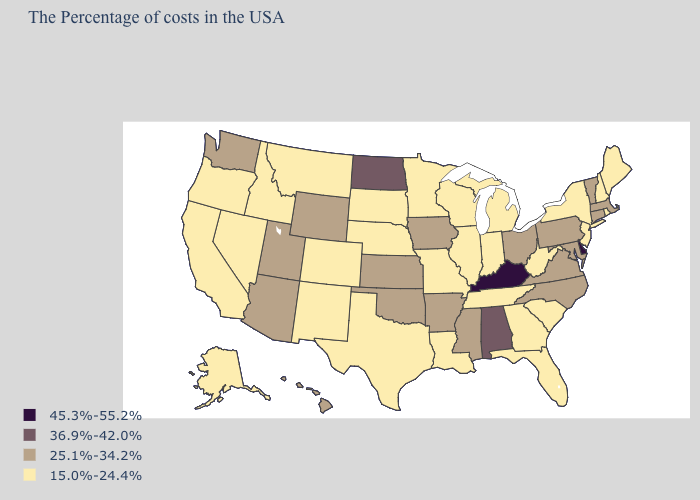Name the states that have a value in the range 45.3%-55.2%?
Be succinct. Delaware, Kentucky. What is the lowest value in the Northeast?
Write a very short answer. 15.0%-24.4%. Does Hawaii have a lower value than Kentucky?
Concise answer only. Yes. Name the states that have a value in the range 15.0%-24.4%?
Give a very brief answer. Maine, Rhode Island, New Hampshire, New York, New Jersey, South Carolina, West Virginia, Florida, Georgia, Michigan, Indiana, Tennessee, Wisconsin, Illinois, Louisiana, Missouri, Minnesota, Nebraska, Texas, South Dakota, Colorado, New Mexico, Montana, Idaho, Nevada, California, Oregon, Alaska. Does West Virginia have the lowest value in the USA?
Keep it brief. Yes. Does the first symbol in the legend represent the smallest category?
Quick response, please. No. Does New Jersey have the same value as Vermont?
Concise answer only. No. Name the states that have a value in the range 45.3%-55.2%?
Give a very brief answer. Delaware, Kentucky. Which states have the highest value in the USA?
Write a very short answer. Delaware, Kentucky. Does New Hampshire have the same value as Indiana?
Short answer required. Yes. What is the value of Indiana?
Short answer required. 15.0%-24.4%. Name the states that have a value in the range 25.1%-34.2%?
Quick response, please. Massachusetts, Vermont, Connecticut, Maryland, Pennsylvania, Virginia, North Carolina, Ohio, Mississippi, Arkansas, Iowa, Kansas, Oklahoma, Wyoming, Utah, Arizona, Washington, Hawaii. Does New Jersey have the lowest value in the USA?
Keep it brief. Yes. What is the value of South Dakota?
Keep it brief. 15.0%-24.4%. Name the states that have a value in the range 45.3%-55.2%?
Short answer required. Delaware, Kentucky. 